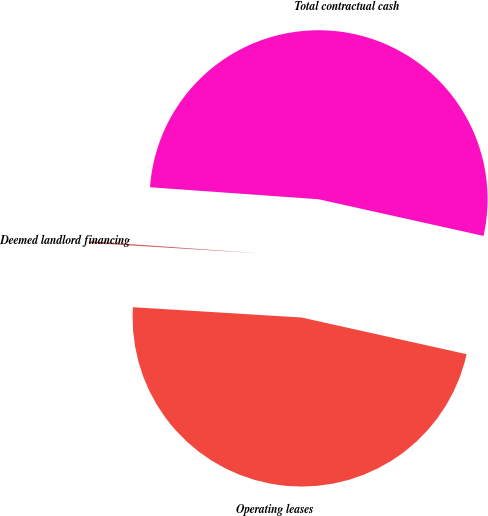Convert chart. <chart><loc_0><loc_0><loc_500><loc_500><pie_chart><fcel>Operating leases<fcel>Deemed landlord financing<fcel>Total contractual cash<nl><fcel>47.49%<fcel>0.16%<fcel>52.35%<nl></chart> 